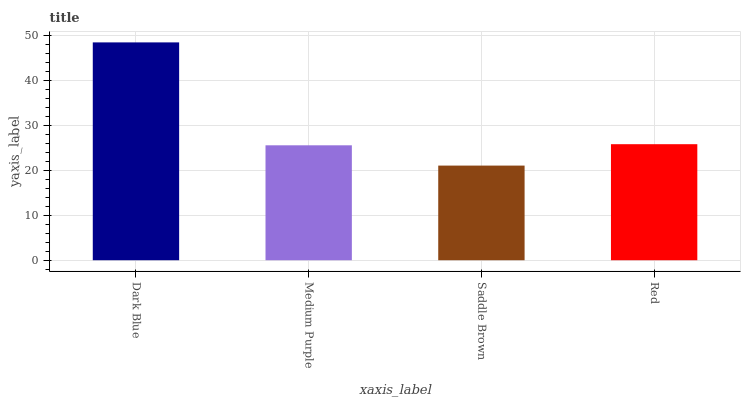Is Saddle Brown the minimum?
Answer yes or no. Yes. Is Dark Blue the maximum?
Answer yes or no. Yes. Is Medium Purple the minimum?
Answer yes or no. No. Is Medium Purple the maximum?
Answer yes or no. No. Is Dark Blue greater than Medium Purple?
Answer yes or no. Yes. Is Medium Purple less than Dark Blue?
Answer yes or no. Yes. Is Medium Purple greater than Dark Blue?
Answer yes or no. No. Is Dark Blue less than Medium Purple?
Answer yes or no. No. Is Red the high median?
Answer yes or no. Yes. Is Medium Purple the low median?
Answer yes or no. Yes. Is Saddle Brown the high median?
Answer yes or no. No. Is Dark Blue the low median?
Answer yes or no. No. 